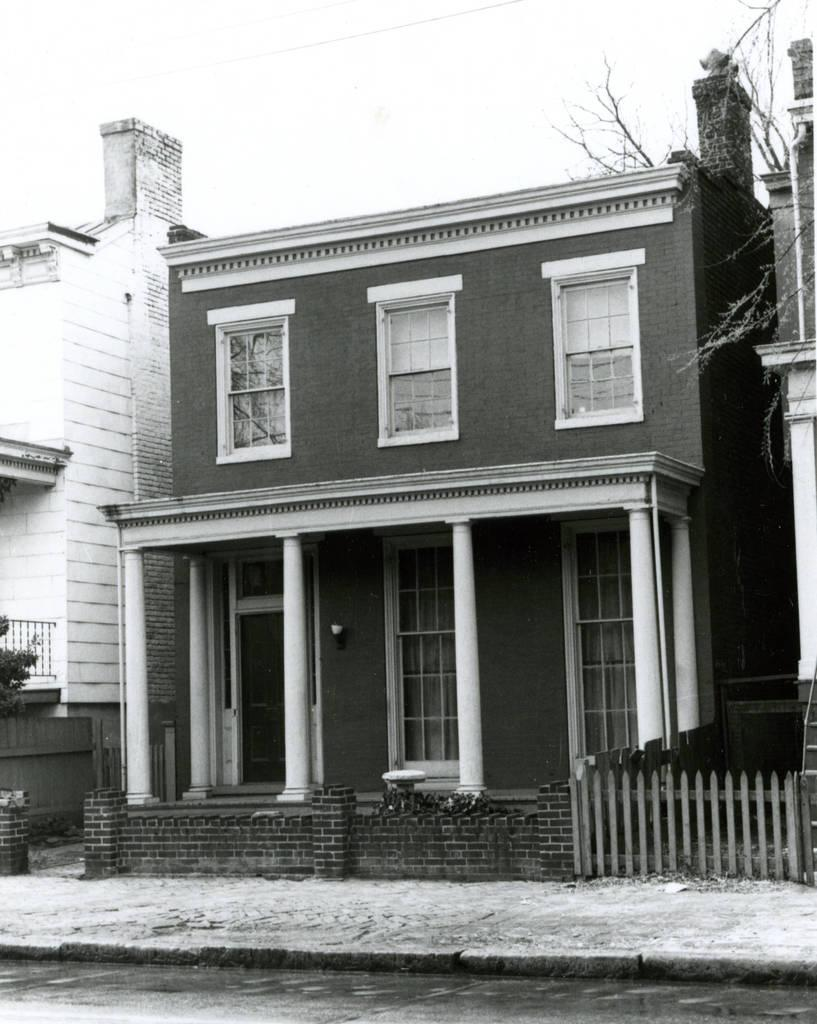What is the color scheme of the image? The image is black and white. What type of structures can be seen in the image? There are buildings in the image. What is visible at the top of the image? The sky is visible at the top of the image. What type of song can be heard playing in the background of the image? There is no sound or music present in the image, so it is not possible to determine what song might be heard. 